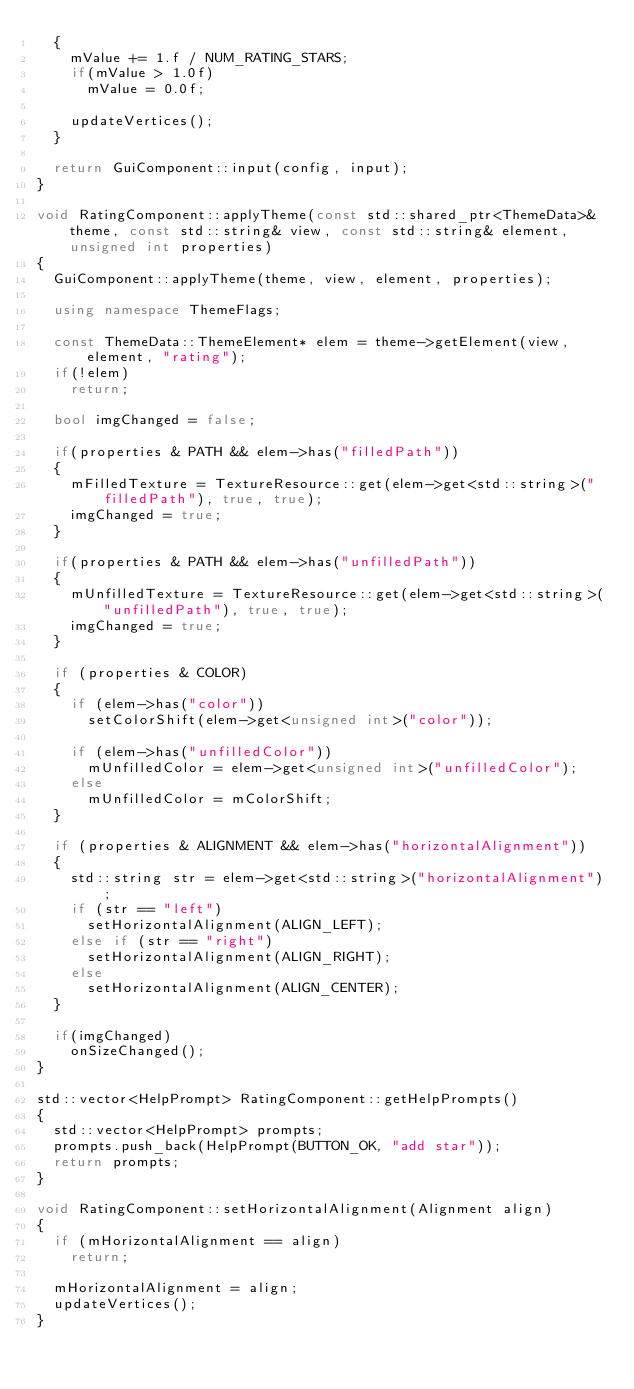Convert code to text. <code><loc_0><loc_0><loc_500><loc_500><_C++_>	{
		mValue += 1.f / NUM_RATING_STARS;
		if(mValue > 1.0f)
			mValue = 0.0f;

		updateVertices();
	}

	return GuiComponent::input(config, input);
}

void RatingComponent::applyTheme(const std::shared_ptr<ThemeData>& theme, const std::string& view, const std::string& element, unsigned int properties)
{
	GuiComponent::applyTheme(theme, view, element, properties);

	using namespace ThemeFlags;

	const ThemeData::ThemeElement* elem = theme->getElement(view, element, "rating");
	if(!elem)
		return;

	bool imgChanged = false;

	if(properties & PATH && elem->has("filledPath"))
	{
		mFilledTexture = TextureResource::get(elem->get<std::string>("filledPath"), true, true);
		imgChanged = true;
	}

	if(properties & PATH && elem->has("unfilledPath"))
	{
		mUnfilledTexture = TextureResource::get(elem->get<std::string>("unfilledPath"), true, true);
		imgChanged = true;
	}
	
	if (properties & COLOR)
	{
		if (elem->has("color"))
			setColorShift(elem->get<unsigned int>("color"));

		if (elem->has("unfilledColor"))
			mUnfilledColor = elem->get<unsigned int>("unfilledColor");
		else
			mUnfilledColor = mColorShift;
	}

	if (properties & ALIGNMENT && elem->has("horizontalAlignment"))
	{
		std::string str = elem->get<std::string>("horizontalAlignment");
		if (str == "left")
			setHorizontalAlignment(ALIGN_LEFT);
		else if (str == "right")
			setHorizontalAlignment(ALIGN_RIGHT);
		else
			setHorizontalAlignment(ALIGN_CENTER);
	}
		
	if(imgChanged)
		onSizeChanged();
}

std::vector<HelpPrompt> RatingComponent::getHelpPrompts()
{
	std::vector<HelpPrompt> prompts;
	prompts.push_back(HelpPrompt(BUTTON_OK, "add star"));
	return prompts;
}

void RatingComponent::setHorizontalAlignment(Alignment align) 
{ 
	if (mHorizontalAlignment == align)
		return;

	mHorizontalAlignment = align; 
	updateVertices();
}</code> 